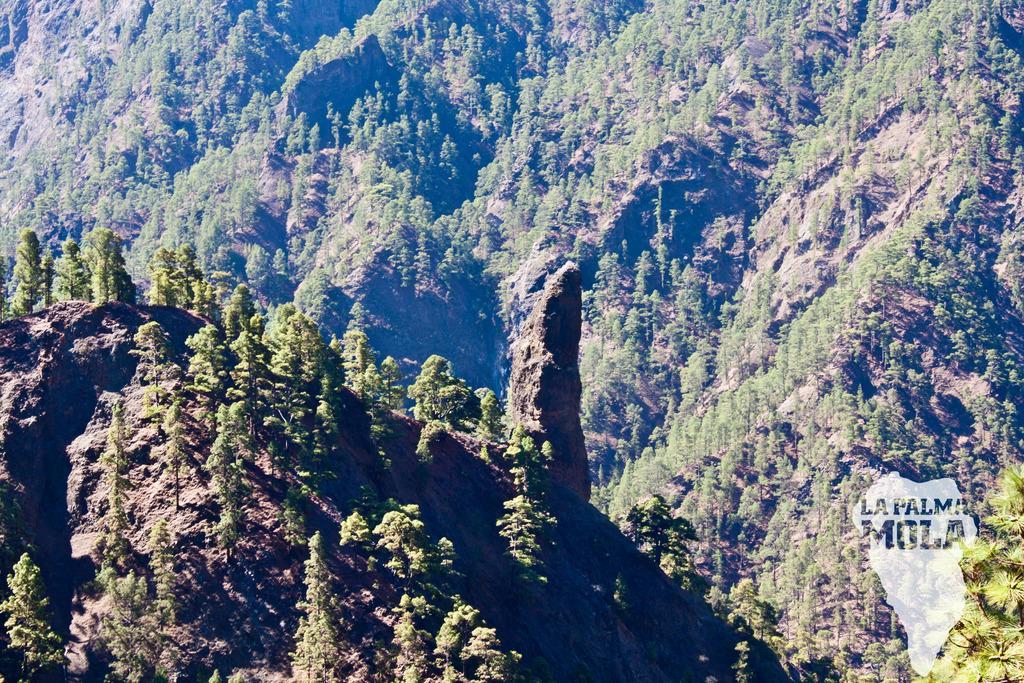In one or two sentences, can you explain what this image depicts? This is an aerial view. In this picture we can see the hills and trees. In the bottom right corner we can see the text and map. 